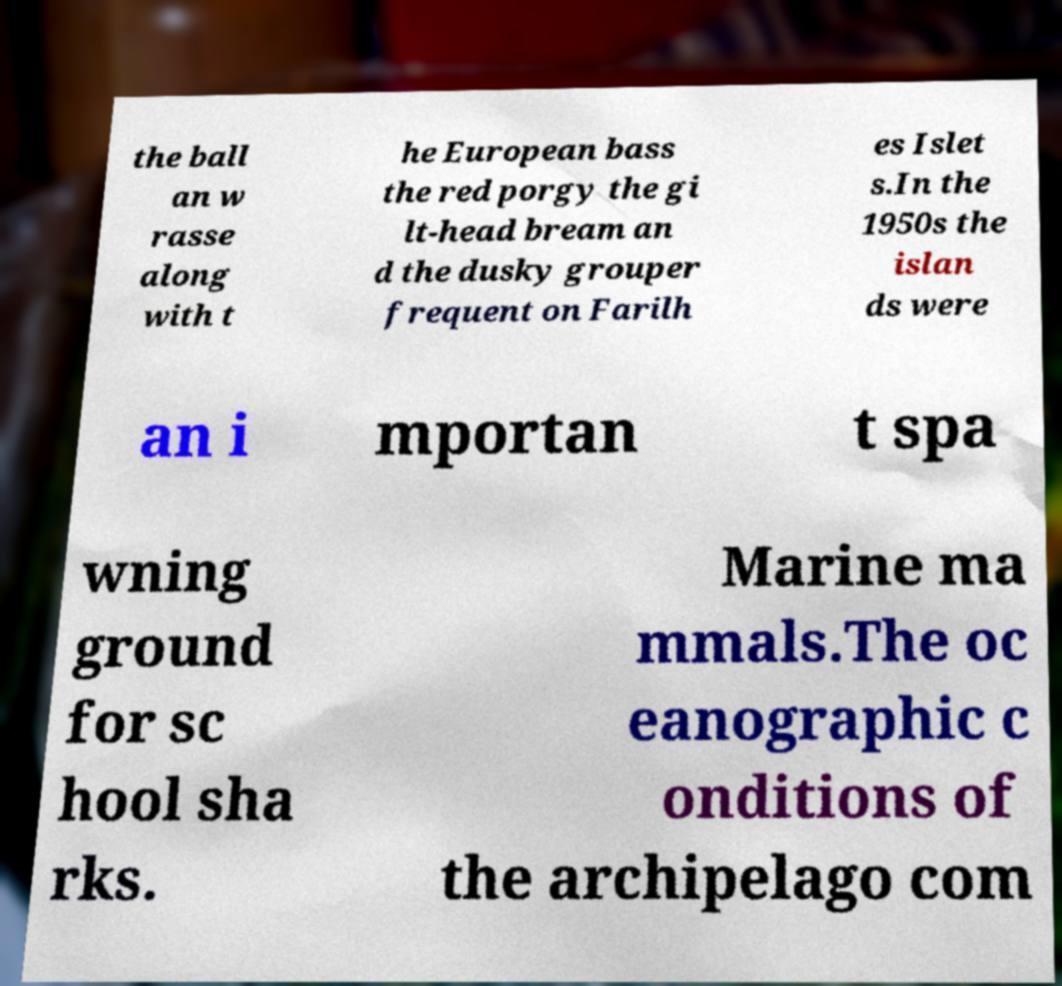Could you assist in decoding the text presented in this image and type it out clearly? the ball an w rasse along with t he European bass the red porgy the gi lt-head bream an d the dusky grouper frequent on Farilh es Islet s.In the 1950s the islan ds were an i mportan t spa wning ground for sc hool sha rks. Marine ma mmals.The oc eanographic c onditions of the archipelago com 